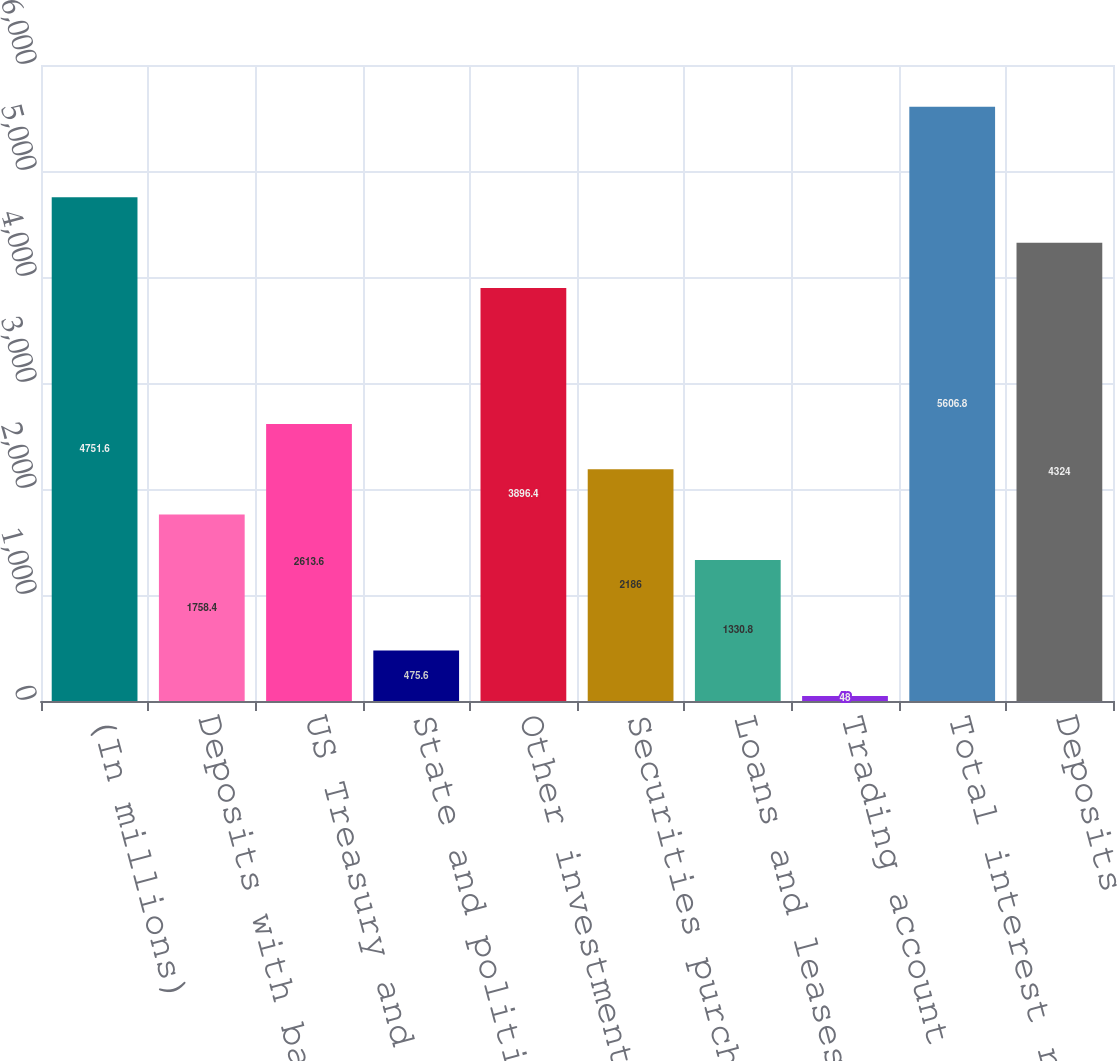Convert chart to OTSL. <chart><loc_0><loc_0><loc_500><loc_500><bar_chart><fcel>(In millions)<fcel>Deposits with banks<fcel>US Treasury and federal<fcel>State and political<fcel>Other investments<fcel>Securities purchased under<fcel>Loans and leases(1)<fcel>Trading account assets<fcel>Total interest revenue<fcel>Deposits<nl><fcel>4751.6<fcel>1758.4<fcel>2613.6<fcel>475.6<fcel>3896.4<fcel>2186<fcel>1330.8<fcel>48<fcel>5606.8<fcel>4324<nl></chart> 